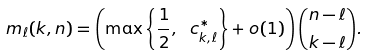Convert formula to latex. <formula><loc_0><loc_0><loc_500><loc_500>m _ { \ell } ( k , n ) = \left ( \max \left \{ \frac { 1 } { 2 } , \ c ^ { * } _ { k , \ell } \right \} + o ( 1 ) \right ) \binom { n - \ell } { k - \ell } .</formula> 